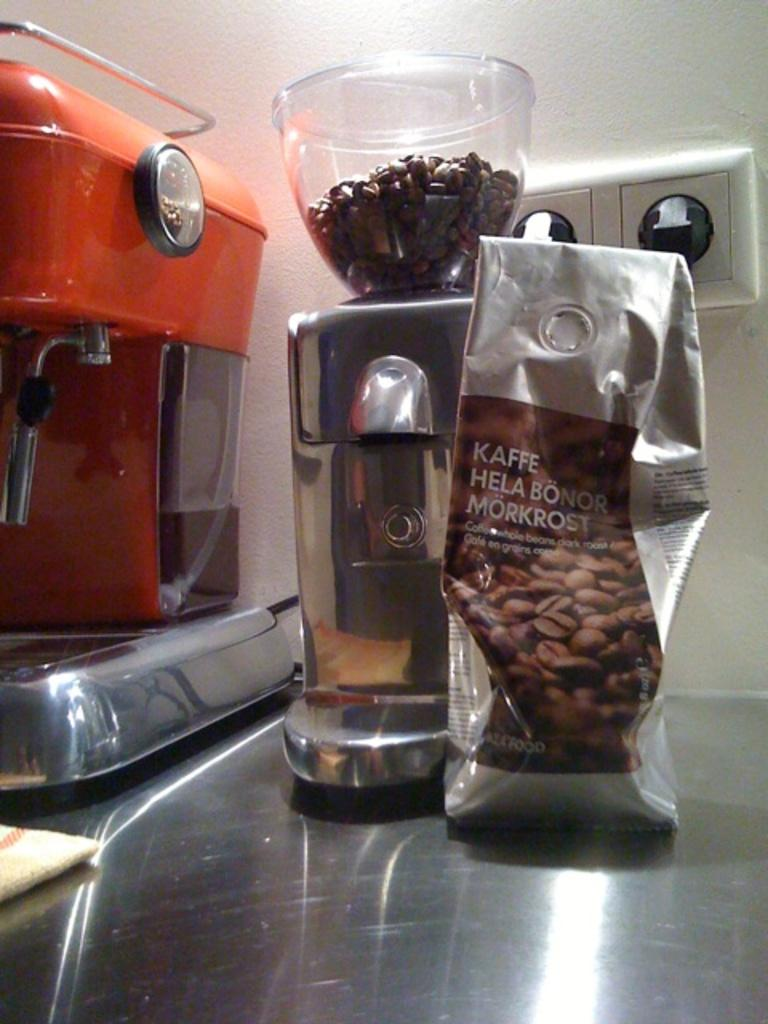<image>
Render a clear and concise summary of the photo. A bag of Kaffe Hela Bonor Morkrost coffee. 